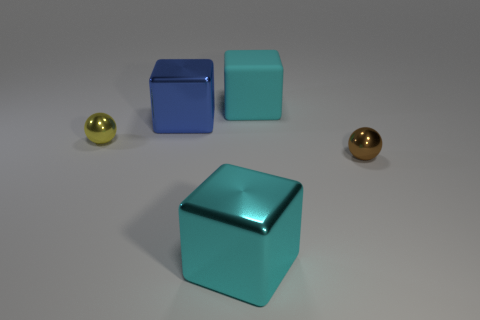There is a metallic object that is both to the right of the big blue block and to the left of the brown sphere; what is its color?
Your answer should be compact. Cyan. What number of other things are the same material as the tiny brown sphere?
Provide a succinct answer. 3. Are there fewer small yellow shiny objects than big green blocks?
Provide a succinct answer. No. Does the tiny yellow thing have the same material as the big cube that is in front of the tiny yellow ball?
Ensure brevity in your answer.  Yes. The small object to the left of the brown metallic object has what shape?
Offer a very short reply. Sphere. Are there any other things that are the same color as the big matte object?
Your answer should be compact. Yes. Are there fewer big metallic things in front of the blue metallic object than large blue objects?
Keep it short and to the point. No. What number of yellow spheres have the same size as the blue thing?
Provide a succinct answer. 0. What shape is the big cyan object that is in front of the ball on the left side of the large cube on the right side of the big cyan metal thing?
Ensure brevity in your answer.  Cube. There is a tiny metal sphere to the right of the cyan rubber block; what color is it?
Provide a short and direct response. Brown. 